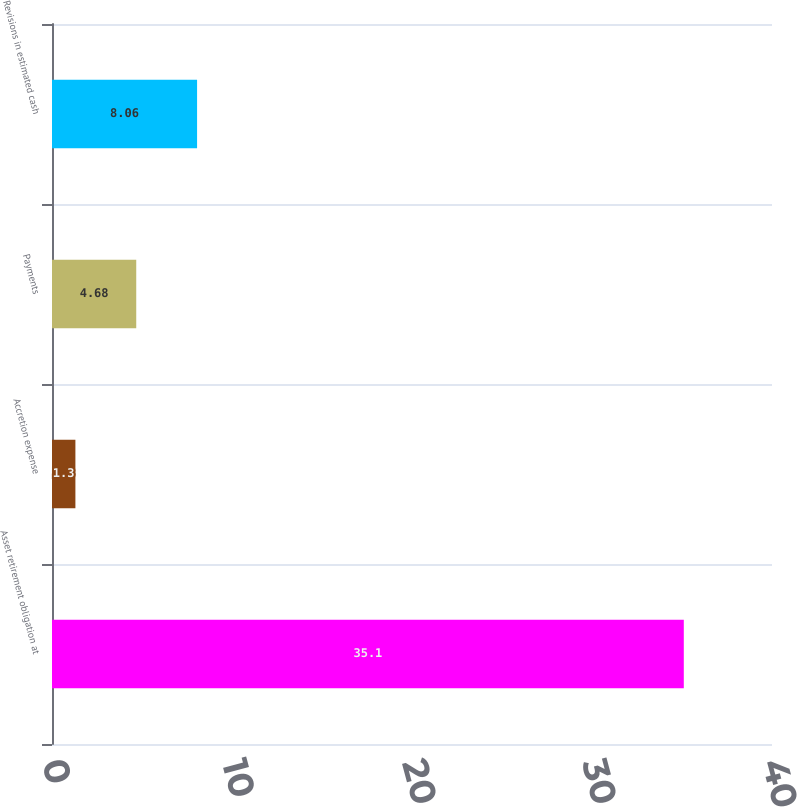Convert chart. <chart><loc_0><loc_0><loc_500><loc_500><bar_chart><fcel>Asset retirement obligation at<fcel>Accretion expense<fcel>Payments<fcel>Revisions in estimated cash<nl><fcel>35.1<fcel>1.3<fcel>4.68<fcel>8.06<nl></chart> 